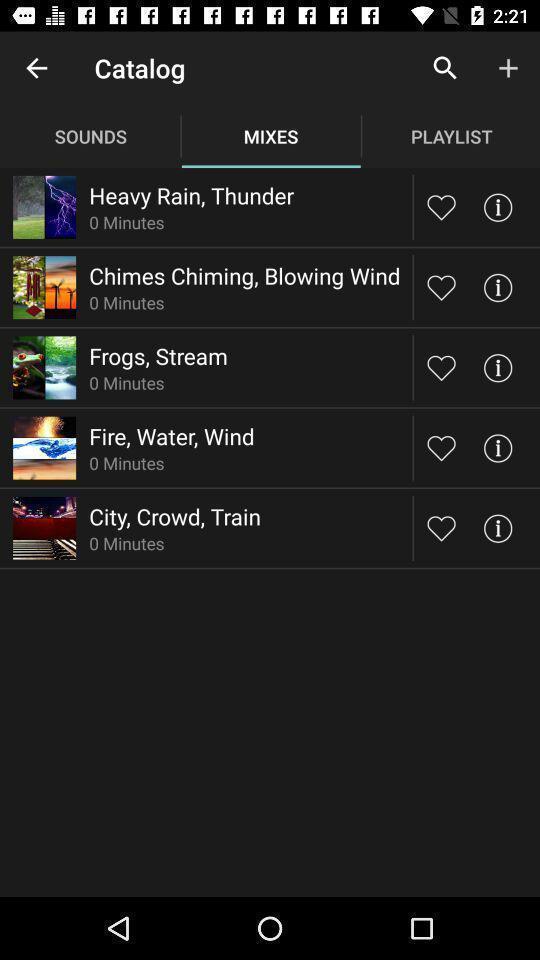Please provide a description for this image. Page displaying multiple sounds. 